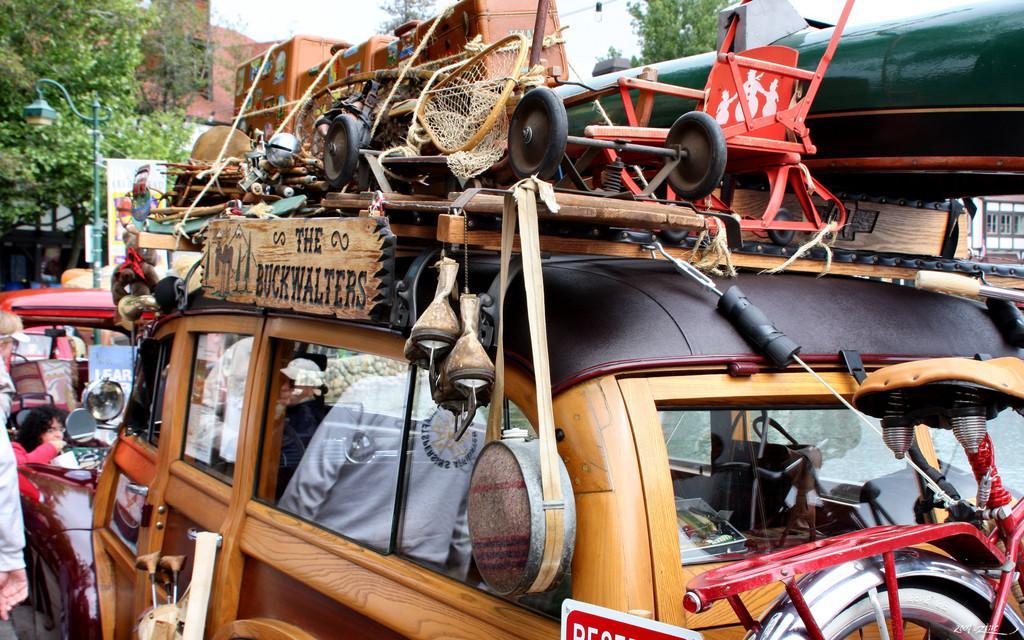Please provide a concise description of this image. In the picture we can see an old car on it, we can see some things are tied on it and in front of the car we can see another car and some persons are standing, and behind we can see a pole with light and trees behind it and beside it we can see a building with windows to it and in the background we can see a sky. 